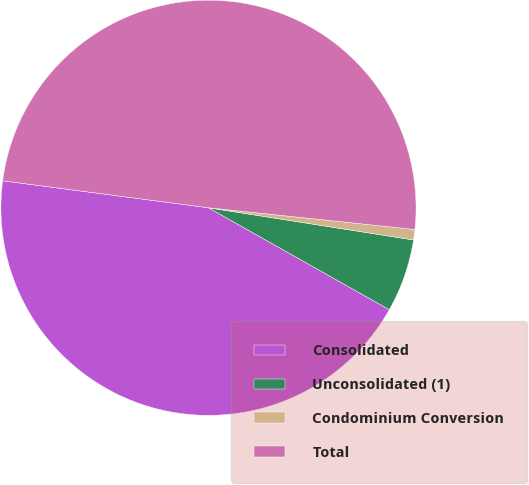<chart> <loc_0><loc_0><loc_500><loc_500><pie_chart><fcel>Consolidated<fcel>Unconsolidated (1)<fcel>Condominium Conversion<fcel>Total<nl><fcel>43.9%<fcel>5.69%<fcel>0.81%<fcel>49.59%<nl></chart> 